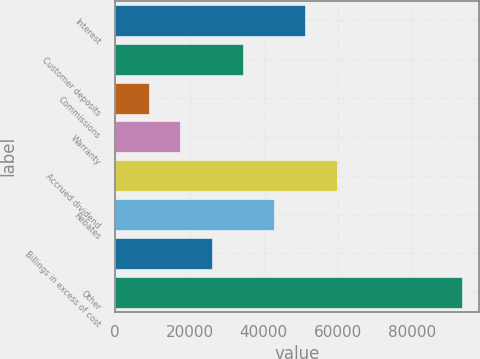Convert chart to OTSL. <chart><loc_0><loc_0><loc_500><loc_500><bar_chart><fcel>Interest<fcel>Customer deposits<fcel>Commissions<fcel>Warranty<fcel>Accrued dividend<fcel>Rebates<fcel>Billings in excess of cost<fcel>Other<nl><fcel>51235<fcel>34398.6<fcel>9144<fcel>17562.2<fcel>59653.2<fcel>42816.8<fcel>25980.4<fcel>93326<nl></chart> 